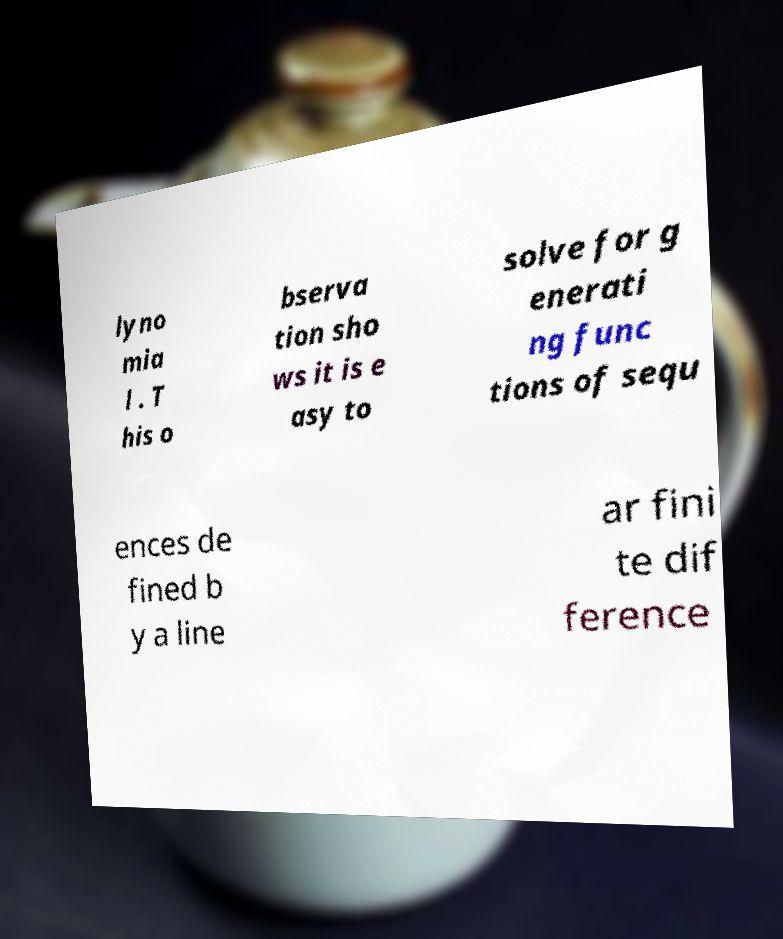Please read and relay the text visible in this image. What does it say? lyno mia l . T his o bserva tion sho ws it is e asy to solve for g enerati ng func tions of sequ ences de fined b y a line ar fini te dif ference 